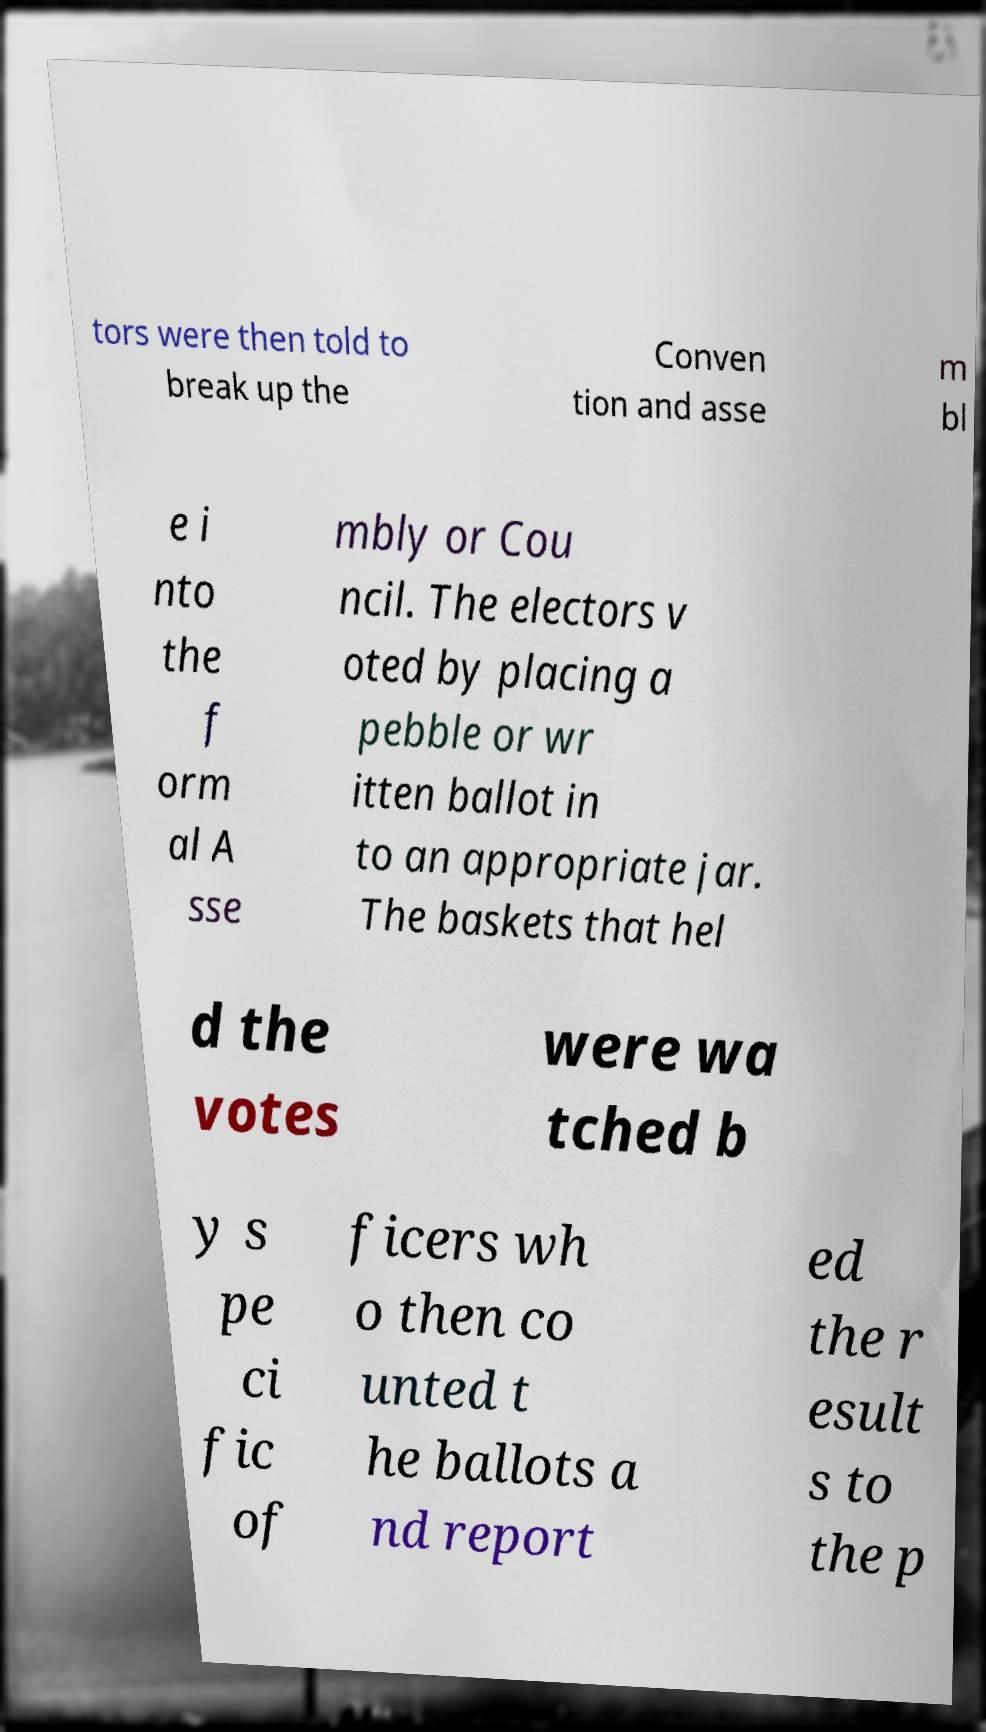There's text embedded in this image that I need extracted. Can you transcribe it verbatim? tors were then told to break up the Conven tion and asse m bl e i nto the f orm al A sse mbly or Cou ncil. The electors v oted by placing a pebble or wr itten ballot in to an appropriate jar. The baskets that hel d the votes were wa tched b y s pe ci fic of ficers wh o then co unted t he ballots a nd report ed the r esult s to the p 